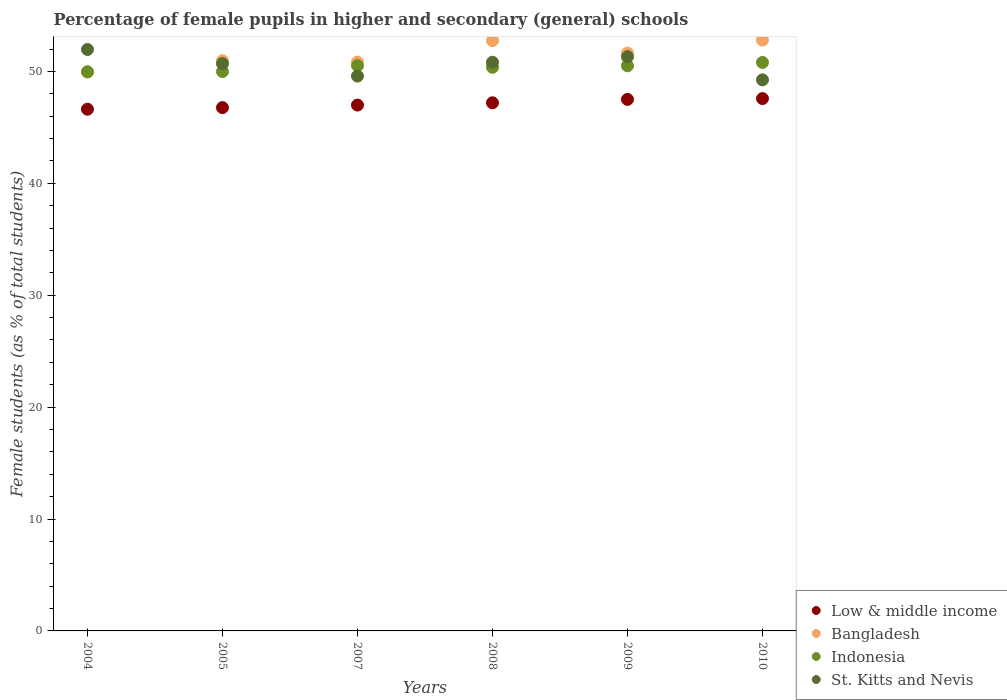How many different coloured dotlines are there?
Keep it short and to the point. 4. What is the percentage of female pupils in higher and secondary schools in Low & middle income in 2004?
Offer a very short reply. 46.62. Across all years, what is the maximum percentage of female pupils in higher and secondary schools in Indonesia?
Your response must be concise. 50.8. Across all years, what is the minimum percentage of female pupils in higher and secondary schools in Indonesia?
Your response must be concise. 49.97. In which year was the percentage of female pupils in higher and secondary schools in St. Kitts and Nevis maximum?
Offer a very short reply. 2004. In which year was the percentage of female pupils in higher and secondary schools in St. Kitts and Nevis minimum?
Your answer should be very brief. 2010. What is the total percentage of female pupils in higher and secondary schools in Indonesia in the graph?
Your answer should be compact. 302.14. What is the difference between the percentage of female pupils in higher and secondary schools in St. Kitts and Nevis in 2008 and that in 2010?
Your answer should be very brief. 1.57. What is the difference between the percentage of female pupils in higher and secondary schools in Low & middle income in 2007 and the percentage of female pupils in higher and secondary schools in Bangladesh in 2008?
Provide a short and direct response. -5.76. What is the average percentage of female pupils in higher and secondary schools in St. Kitts and Nevis per year?
Ensure brevity in your answer.  50.6. In the year 2009, what is the difference between the percentage of female pupils in higher and secondary schools in Low & middle income and percentage of female pupils in higher and secondary schools in Indonesia?
Your answer should be very brief. -3. In how many years, is the percentage of female pupils in higher and secondary schools in Bangladesh greater than 46 %?
Make the answer very short. 6. What is the ratio of the percentage of female pupils in higher and secondary schools in Bangladesh in 2005 to that in 2010?
Ensure brevity in your answer.  0.97. What is the difference between the highest and the second highest percentage of female pupils in higher and secondary schools in St. Kitts and Nevis?
Make the answer very short. 0.65. What is the difference between the highest and the lowest percentage of female pupils in higher and secondary schools in St. Kitts and Nevis?
Provide a succinct answer. 2.71. In how many years, is the percentage of female pupils in higher and secondary schools in Indonesia greater than the average percentage of female pupils in higher and secondary schools in Indonesia taken over all years?
Make the answer very short. 4. Is the sum of the percentage of female pupils in higher and secondary schools in Indonesia in 2004 and 2007 greater than the maximum percentage of female pupils in higher and secondary schools in Low & middle income across all years?
Offer a very short reply. Yes. Is it the case that in every year, the sum of the percentage of female pupils in higher and secondary schools in Bangladesh and percentage of female pupils in higher and secondary schools in St. Kitts and Nevis  is greater than the sum of percentage of female pupils in higher and secondary schools in Low & middle income and percentage of female pupils in higher and secondary schools in Indonesia?
Your response must be concise. No. Does the percentage of female pupils in higher and secondary schools in Bangladesh monotonically increase over the years?
Offer a terse response. No. Is the percentage of female pupils in higher and secondary schools in St. Kitts and Nevis strictly less than the percentage of female pupils in higher and secondary schools in Bangladesh over the years?
Keep it short and to the point. No. How many dotlines are there?
Provide a succinct answer. 4. How many years are there in the graph?
Your answer should be very brief. 6. What is the difference between two consecutive major ticks on the Y-axis?
Provide a short and direct response. 10. How many legend labels are there?
Make the answer very short. 4. How are the legend labels stacked?
Keep it short and to the point. Vertical. What is the title of the graph?
Ensure brevity in your answer.  Percentage of female pupils in higher and secondary (general) schools. What is the label or title of the Y-axis?
Offer a very short reply. Female students (as % of total students). What is the Female students (as % of total students) of Low & middle income in 2004?
Offer a very short reply. 46.62. What is the Female students (as % of total students) of Bangladesh in 2004?
Offer a terse response. 49.95. What is the Female students (as % of total students) in Indonesia in 2004?
Your response must be concise. 49.97. What is the Female students (as % of total students) of St. Kitts and Nevis in 2004?
Your response must be concise. 51.96. What is the Female students (as % of total students) of Low & middle income in 2005?
Make the answer very short. 46.76. What is the Female students (as % of total students) in Bangladesh in 2005?
Provide a short and direct response. 50.96. What is the Female students (as % of total students) of Indonesia in 2005?
Offer a terse response. 49.99. What is the Female students (as % of total students) in St. Kitts and Nevis in 2005?
Make the answer very short. 50.7. What is the Female students (as % of total students) of Low & middle income in 2007?
Provide a short and direct response. 46.99. What is the Female students (as % of total students) in Bangladesh in 2007?
Offer a terse response. 50.83. What is the Female students (as % of total students) of Indonesia in 2007?
Your answer should be compact. 50.51. What is the Female students (as % of total students) in St. Kitts and Nevis in 2007?
Provide a succinct answer. 49.58. What is the Female students (as % of total students) of Low & middle income in 2008?
Provide a succinct answer. 47.2. What is the Female students (as % of total students) in Bangladesh in 2008?
Make the answer very short. 52.76. What is the Female students (as % of total students) of Indonesia in 2008?
Provide a short and direct response. 50.37. What is the Female students (as % of total students) of St. Kitts and Nevis in 2008?
Provide a short and direct response. 50.82. What is the Female students (as % of total students) of Low & middle income in 2009?
Make the answer very short. 47.5. What is the Female students (as % of total students) of Bangladesh in 2009?
Ensure brevity in your answer.  51.63. What is the Female students (as % of total students) of Indonesia in 2009?
Ensure brevity in your answer.  50.5. What is the Female students (as % of total students) of St. Kitts and Nevis in 2009?
Make the answer very short. 51.31. What is the Female students (as % of total students) of Low & middle income in 2010?
Provide a succinct answer. 47.57. What is the Female students (as % of total students) in Bangladesh in 2010?
Your response must be concise. 52.8. What is the Female students (as % of total students) of Indonesia in 2010?
Your answer should be very brief. 50.8. What is the Female students (as % of total students) in St. Kitts and Nevis in 2010?
Offer a terse response. 49.25. Across all years, what is the maximum Female students (as % of total students) of Low & middle income?
Offer a terse response. 47.57. Across all years, what is the maximum Female students (as % of total students) in Bangladesh?
Give a very brief answer. 52.8. Across all years, what is the maximum Female students (as % of total students) in Indonesia?
Your response must be concise. 50.8. Across all years, what is the maximum Female students (as % of total students) of St. Kitts and Nevis?
Provide a succinct answer. 51.96. Across all years, what is the minimum Female students (as % of total students) in Low & middle income?
Keep it short and to the point. 46.62. Across all years, what is the minimum Female students (as % of total students) in Bangladesh?
Make the answer very short. 49.95. Across all years, what is the minimum Female students (as % of total students) in Indonesia?
Your answer should be very brief. 49.97. Across all years, what is the minimum Female students (as % of total students) in St. Kitts and Nevis?
Offer a very short reply. 49.25. What is the total Female students (as % of total students) of Low & middle income in the graph?
Make the answer very short. 282.65. What is the total Female students (as % of total students) of Bangladesh in the graph?
Offer a terse response. 308.93. What is the total Female students (as % of total students) in Indonesia in the graph?
Give a very brief answer. 302.14. What is the total Female students (as % of total students) of St. Kitts and Nevis in the graph?
Your response must be concise. 303.61. What is the difference between the Female students (as % of total students) in Low & middle income in 2004 and that in 2005?
Give a very brief answer. -0.14. What is the difference between the Female students (as % of total students) of Bangladesh in 2004 and that in 2005?
Provide a succinct answer. -1.01. What is the difference between the Female students (as % of total students) of Indonesia in 2004 and that in 2005?
Offer a terse response. -0.02. What is the difference between the Female students (as % of total students) in St. Kitts and Nevis in 2004 and that in 2005?
Offer a terse response. 1.26. What is the difference between the Female students (as % of total students) in Low & middle income in 2004 and that in 2007?
Give a very brief answer. -0.37. What is the difference between the Female students (as % of total students) in Bangladesh in 2004 and that in 2007?
Your answer should be very brief. -0.88. What is the difference between the Female students (as % of total students) of Indonesia in 2004 and that in 2007?
Make the answer very short. -0.55. What is the difference between the Female students (as % of total students) of St. Kitts and Nevis in 2004 and that in 2007?
Ensure brevity in your answer.  2.38. What is the difference between the Female students (as % of total students) in Low & middle income in 2004 and that in 2008?
Provide a succinct answer. -0.57. What is the difference between the Female students (as % of total students) in Bangladesh in 2004 and that in 2008?
Your response must be concise. -2.81. What is the difference between the Female students (as % of total students) of Indonesia in 2004 and that in 2008?
Ensure brevity in your answer.  -0.4. What is the difference between the Female students (as % of total students) of St. Kitts and Nevis in 2004 and that in 2008?
Keep it short and to the point. 1.14. What is the difference between the Female students (as % of total students) of Low & middle income in 2004 and that in 2009?
Your answer should be compact. -0.88. What is the difference between the Female students (as % of total students) in Bangladesh in 2004 and that in 2009?
Ensure brevity in your answer.  -1.68. What is the difference between the Female students (as % of total students) of Indonesia in 2004 and that in 2009?
Your answer should be compact. -0.54. What is the difference between the Female students (as % of total students) of St. Kitts and Nevis in 2004 and that in 2009?
Your answer should be very brief. 0.65. What is the difference between the Female students (as % of total students) of Low & middle income in 2004 and that in 2010?
Offer a very short reply. -0.95. What is the difference between the Female students (as % of total students) of Bangladesh in 2004 and that in 2010?
Your answer should be compact. -2.85. What is the difference between the Female students (as % of total students) of Indonesia in 2004 and that in 2010?
Provide a short and direct response. -0.84. What is the difference between the Female students (as % of total students) of St. Kitts and Nevis in 2004 and that in 2010?
Offer a terse response. 2.71. What is the difference between the Female students (as % of total students) of Low & middle income in 2005 and that in 2007?
Provide a short and direct response. -0.23. What is the difference between the Female students (as % of total students) of Bangladesh in 2005 and that in 2007?
Offer a very short reply. 0.13. What is the difference between the Female students (as % of total students) of Indonesia in 2005 and that in 2007?
Your answer should be very brief. -0.53. What is the difference between the Female students (as % of total students) in St. Kitts and Nevis in 2005 and that in 2007?
Keep it short and to the point. 1.12. What is the difference between the Female students (as % of total students) in Low & middle income in 2005 and that in 2008?
Keep it short and to the point. -0.43. What is the difference between the Female students (as % of total students) of Bangladesh in 2005 and that in 2008?
Offer a terse response. -1.8. What is the difference between the Female students (as % of total students) in Indonesia in 2005 and that in 2008?
Provide a succinct answer. -0.38. What is the difference between the Female students (as % of total students) of St. Kitts and Nevis in 2005 and that in 2008?
Offer a terse response. -0.12. What is the difference between the Female students (as % of total students) in Low & middle income in 2005 and that in 2009?
Offer a very short reply. -0.74. What is the difference between the Female students (as % of total students) of Bangladesh in 2005 and that in 2009?
Offer a very short reply. -0.68. What is the difference between the Female students (as % of total students) of Indonesia in 2005 and that in 2009?
Offer a terse response. -0.52. What is the difference between the Female students (as % of total students) in St. Kitts and Nevis in 2005 and that in 2009?
Make the answer very short. -0.61. What is the difference between the Female students (as % of total students) of Low & middle income in 2005 and that in 2010?
Ensure brevity in your answer.  -0.81. What is the difference between the Female students (as % of total students) in Bangladesh in 2005 and that in 2010?
Keep it short and to the point. -1.85. What is the difference between the Female students (as % of total students) in Indonesia in 2005 and that in 2010?
Your response must be concise. -0.81. What is the difference between the Female students (as % of total students) in St. Kitts and Nevis in 2005 and that in 2010?
Provide a short and direct response. 1.45. What is the difference between the Female students (as % of total students) of Low & middle income in 2007 and that in 2008?
Give a very brief answer. -0.2. What is the difference between the Female students (as % of total students) in Bangladesh in 2007 and that in 2008?
Make the answer very short. -1.93. What is the difference between the Female students (as % of total students) of Indonesia in 2007 and that in 2008?
Your answer should be very brief. 0.15. What is the difference between the Female students (as % of total students) in St. Kitts and Nevis in 2007 and that in 2008?
Your answer should be very brief. -1.24. What is the difference between the Female students (as % of total students) of Low & middle income in 2007 and that in 2009?
Ensure brevity in your answer.  -0.51. What is the difference between the Female students (as % of total students) of Bangladesh in 2007 and that in 2009?
Your answer should be compact. -0.8. What is the difference between the Female students (as % of total students) in Indonesia in 2007 and that in 2009?
Offer a terse response. 0.01. What is the difference between the Female students (as % of total students) in St. Kitts and Nevis in 2007 and that in 2009?
Provide a short and direct response. -1.73. What is the difference between the Female students (as % of total students) of Low & middle income in 2007 and that in 2010?
Make the answer very short. -0.58. What is the difference between the Female students (as % of total students) of Bangladesh in 2007 and that in 2010?
Your answer should be very brief. -1.97. What is the difference between the Female students (as % of total students) of Indonesia in 2007 and that in 2010?
Keep it short and to the point. -0.29. What is the difference between the Female students (as % of total students) in St. Kitts and Nevis in 2007 and that in 2010?
Ensure brevity in your answer.  0.33. What is the difference between the Female students (as % of total students) in Low & middle income in 2008 and that in 2009?
Your response must be concise. -0.3. What is the difference between the Female students (as % of total students) in Bangladesh in 2008 and that in 2009?
Provide a short and direct response. 1.12. What is the difference between the Female students (as % of total students) of Indonesia in 2008 and that in 2009?
Provide a short and direct response. -0.13. What is the difference between the Female students (as % of total students) of St. Kitts and Nevis in 2008 and that in 2009?
Your answer should be compact. -0.49. What is the difference between the Female students (as % of total students) of Low & middle income in 2008 and that in 2010?
Offer a terse response. -0.38. What is the difference between the Female students (as % of total students) in Bangladesh in 2008 and that in 2010?
Offer a very short reply. -0.05. What is the difference between the Female students (as % of total students) in Indonesia in 2008 and that in 2010?
Provide a succinct answer. -0.43. What is the difference between the Female students (as % of total students) of St. Kitts and Nevis in 2008 and that in 2010?
Offer a terse response. 1.57. What is the difference between the Female students (as % of total students) in Low & middle income in 2009 and that in 2010?
Make the answer very short. -0.07. What is the difference between the Female students (as % of total students) of Bangladesh in 2009 and that in 2010?
Provide a short and direct response. -1.17. What is the difference between the Female students (as % of total students) of Indonesia in 2009 and that in 2010?
Make the answer very short. -0.3. What is the difference between the Female students (as % of total students) of St. Kitts and Nevis in 2009 and that in 2010?
Ensure brevity in your answer.  2.07. What is the difference between the Female students (as % of total students) in Low & middle income in 2004 and the Female students (as % of total students) in Bangladesh in 2005?
Ensure brevity in your answer.  -4.34. What is the difference between the Female students (as % of total students) of Low & middle income in 2004 and the Female students (as % of total students) of Indonesia in 2005?
Your answer should be very brief. -3.37. What is the difference between the Female students (as % of total students) of Low & middle income in 2004 and the Female students (as % of total students) of St. Kitts and Nevis in 2005?
Your answer should be compact. -4.08. What is the difference between the Female students (as % of total students) in Bangladesh in 2004 and the Female students (as % of total students) in Indonesia in 2005?
Ensure brevity in your answer.  -0.04. What is the difference between the Female students (as % of total students) of Bangladesh in 2004 and the Female students (as % of total students) of St. Kitts and Nevis in 2005?
Your answer should be compact. -0.75. What is the difference between the Female students (as % of total students) in Indonesia in 2004 and the Female students (as % of total students) in St. Kitts and Nevis in 2005?
Make the answer very short. -0.73. What is the difference between the Female students (as % of total students) of Low & middle income in 2004 and the Female students (as % of total students) of Bangladesh in 2007?
Your answer should be very brief. -4.21. What is the difference between the Female students (as % of total students) of Low & middle income in 2004 and the Female students (as % of total students) of Indonesia in 2007?
Your response must be concise. -3.89. What is the difference between the Female students (as % of total students) in Low & middle income in 2004 and the Female students (as % of total students) in St. Kitts and Nevis in 2007?
Provide a succinct answer. -2.96. What is the difference between the Female students (as % of total students) of Bangladesh in 2004 and the Female students (as % of total students) of Indonesia in 2007?
Provide a succinct answer. -0.56. What is the difference between the Female students (as % of total students) in Bangladesh in 2004 and the Female students (as % of total students) in St. Kitts and Nevis in 2007?
Make the answer very short. 0.37. What is the difference between the Female students (as % of total students) in Indonesia in 2004 and the Female students (as % of total students) in St. Kitts and Nevis in 2007?
Your answer should be very brief. 0.39. What is the difference between the Female students (as % of total students) in Low & middle income in 2004 and the Female students (as % of total students) in Bangladesh in 2008?
Ensure brevity in your answer.  -6.13. What is the difference between the Female students (as % of total students) of Low & middle income in 2004 and the Female students (as % of total students) of Indonesia in 2008?
Your response must be concise. -3.75. What is the difference between the Female students (as % of total students) of Low & middle income in 2004 and the Female students (as % of total students) of St. Kitts and Nevis in 2008?
Your response must be concise. -4.2. What is the difference between the Female students (as % of total students) in Bangladesh in 2004 and the Female students (as % of total students) in Indonesia in 2008?
Offer a terse response. -0.42. What is the difference between the Female students (as % of total students) of Bangladesh in 2004 and the Female students (as % of total students) of St. Kitts and Nevis in 2008?
Provide a succinct answer. -0.87. What is the difference between the Female students (as % of total students) in Indonesia in 2004 and the Female students (as % of total students) in St. Kitts and Nevis in 2008?
Your answer should be compact. -0.85. What is the difference between the Female students (as % of total students) in Low & middle income in 2004 and the Female students (as % of total students) in Bangladesh in 2009?
Ensure brevity in your answer.  -5.01. What is the difference between the Female students (as % of total students) in Low & middle income in 2004 and the Female students (as % of total students) in Indonesia in 2009?
Offer a terse response. -3.88. What is the difference between the Female students (as % of total students) of Low & middle income in 2004 and the Female students (as % of total students) of St. Kitts and Nevis in 2009?
Provide a succinct answer. -4.69. What is the difference between the Female students (as % of total students) in Bangladesh in 2004 and the Female students (as % of total students) in Indonesia in 2009?
Provide a succinct answer. -0.55. What is the difference between the Female students (as % of total students) of Bangladesh in 2004 and the Female students (as % of total students) of St. Kitts and Nevis in 2009?
Offer a terse response. -1.36. What is the difference between the Female students (as % of total students) in Indonesia in 2004 and the Female students (as % of total students) in St. Kitts and Nevis in 2009?
Your answer should be compact. -1.35. What is the difference between the Female students (as % of total students) in Low & middle income in 2004 and the Female students (as % of total students) in Bangladesh in 2010?
Make the answer very short. -6.18. What is the difference between the Female students (as % of total students) of Low & middle income in 2004 and the Female students (as % of total students) of Indonesia in 2010?
Ensure brevity in your answer.  -4.18. What is the difference between the Female students (as % of total students) of Low & middle income in 2004 and the Female students (as % of total students) of St. Kitts and Nevis in 2010?
Keep it short and to the point. -2.62. What is the difference between the Female students (as % of total students) in Bangladesh in 2004 and the Female students (as % of total students) in Indonesia in 2010?
Give a very brief answer. -0.85. What is the difference between the Female students (as % of total students) of Bangladesh in 2004 and the Female students (as % of total students) of St. Kitts and Nevis in 2010?
Provide a short and direct response. 0.7. What is the difference between the Female students (as % of total students) of Indonesia in 2004 and the Female students (as % of total students) of St. Kitts and Nevis in 2010?
Your response must be concise. 0.72. What is the difference between the Female students (as % of total students) of Low & middle income in 2005 and the Female students (as % of total students) of Bangladesh in 2007?
Offer a very short reply. -4.07. What is the difference between the Female students (as % of total students) in Low & middle income in 2005 and the Female students (as % of total students) in Indonesia in 2007?
Ensure brevity in your answer.  -3.75. What is the difference between the Female students (as % of total students) of Low & middle income in 2005 and the Female students (as % of total students) of St. Kitts and Nevis in 2007?
Offer a terse response. -2.82. What is the difference between the Female students (as % of total students) in Bangladesh in 2005 and the Female students (as % of total students) in Indonesia in 2007?
Offer a very short reply. 0.44. What is the difference between the Female students (as % of total students) of Bangladesh in 2005 and the Female students (as % of total students) of St. Kitts and Nevis in 2007?
Ensure brevity in your answer.  1.38. What is the difference between the Female students (as % of total students) in Indonesia in 2005 and the Female students (as % of total students) in St. Kitts and Nevis in 2007?
Give a very brief answer. 0.41. What is the difference between the Female students (as % of total students) of Low & middle income in 2005 and the Female students (as % of total students) of Bangladesh in 2008?
Your answer should be compact. -5.99. What is the difference between the Female students (as % of total students) of Low & middle income in 2005 and the Female students (as % of total students) of Indonesia in 2008?
Offer a terse response. -3.6. What is the difference between the Female students (as % of total students) in Low & middle income in 2005 and the Female students (as % of total students) in St. Kitts and Nevis in 2008?
Offer a very short reply. -4.05. What is the difference between the Female students (as % of total students) of Bangladesh in 2005 and the Female students (as % of total students) of Indonesia in 2008?
Your response must be concise. 0.59. What is the difference between the Female students (as % of total students) in Bangladesh in 2005 and the Female students (as % of total students) in St. Kitts and Nevis in 2008?
Your answer should be compact. 0.14. What is the difference between the Female students (as % of total students) of Indonesia in 2005 and the Female students (as % of total students) of St. Kitts and Nevis in 2008?
Your answer should be compact. -0.83. What is the difference between the Female students (as % of total students) of Low & middle income in 2005 and the Female students (as % of total students) of Bangladesh in 2009?
Keep it short and to the point. -4.87. What is the difference between the Female students (as % of total students) of Low & middle income in 2005 and the Female students (as % of total students) of Indonesia in 2009?
Your response must be concise. -3.74. What is the difference between the Female students (as % of total students) in Low & middle income in 2005 and the Female students (as % of total students) in St. Kitts and Nevis in 2009?
Keep it short and to the point. -4.55. What is the difference between the Female students (as % of total students) in Bangladesh in 2005 and the Female students (as % of total students) in Indonesia in 2009?
Offer a terse response. 0.46. What is the difference between the Female students (as % of total students) in Bangladesh in 2005 and the Female students (as % of total students) in St. Kitts and Nevis in 2009?
Your response must be concise. -0.35. What is the difference between the Female students (as % of total students) in Indonesia in 2005 and the Female students (as % of total students) in St. Kitts and Nevis in 2009?
Your response must be concise. -1.32. What is the difference between the Female students (as % of total students) in Low & middle income in 2005 and the Female students (as % of total students) in Bangladesh in 2010?
Give a very brief answer. -6.04. What is the difference between the Female students (as % of total students) of Low & middle income in 2005 and the Female students (as % of total students) of Indonesia in 2010?
Your answer should be compact. -4.04. What is the difference between the Female students (as % of total students) of Low & middle income in 2005 and the Female students (as % of total students) of St. Kitts and Nevis in 2010?
Your answer should be compact. -2.48. What is the difference between the Female students (as % of total students) in Bangladesh in 2005 and the Female students (as % of total students) in Indonesia in 2010?
Offer a terse response. 0.16. What is the difference between the Female students (as % of total students) of Bangladesh in 2005 and the Female students (as % of total students) of St. Kitts and Nevis in 2010?
Give a very brief answer. 1.71. What is the difference between the Female students (as % of total students) of Indonesia in 2005 and the Female students (as % of total students) of St. Kitts and Nevis in 2010?
Make the answer very short. 0.74. What is the difference between the Female students (as % of total students) in Low & middle income in 2007 and the Female students (as % of total students) in Bangladesh in 2008?
Provide a short and direct response. -5.76. What is the difference between the Female students (as % of total students) in Low & middle income in 2007 and the Female students (as % of total students) in Indonesia in 2008?
Your response must be concise. -3.38. What is the difference between the Female students (as % of total students) of Low & middle income in 2007 and the Female students (as % of total students) of St. Kitts and Nevis in 2008?
Provide a succinct answer. -3.83. What is the difference between the Female students (as % of total students) in Bangladesh in 2007 and the Female students (as % of total students) in Indonesia in 2008?
Provide a short and direct response. 0.46. What is the difference between the Female students (as % of total students) in Bangladesh in 2007 and the Female students (as % of total students) in St. Kitts and Nevis in 2008?
Ensure brevity in your answer.  0.01. What is the difference between the Female students (as % of total students) of Indonesia in 2007 and the Female students (as % of total students) of St. Kitts and Nevis in 2008?
Give a very brief answer. -0.31. What is the difference between the Female students (as % of total students) of Low & middle income in 2007 and the Female students (as % of total students) of Bangladesh in 2009?
Ensure brevity in your answer.  -4.64. What is the difference between the Female students (as % of total students) in Low & middle income in 2007 and the Female students (as % of total students) in Indonesia in 2009?
Ensure brevity in your answer.  -3.51. What is the difference between the Female students (as % of total students) of Low & middle income in 2007 and the Female students (as % of total students) of St. Kitts and Nevis in 2009?
Offer a terse response. -4.32. What is the difference between the Female students (as % of total students) of Bangladesh in 2007 and the Female students (as % of total students) of Indonesia in 2009?
Make the answer very short. 0.33. What is the difference between the Female students (as % of total students) of Bangladesh in 2007 and the Female students (as % of total students) of St. Kitts and Nevis in 2009?
Provide a succinct answer. -0.48. What is the difference between the Female students (as % of total students) of Indonesia in 2007 and the Female students (as % of total students) of St. Kitts and Nevis in 2009?
Ensure brevity in your answer.  -0.8. What is the difference between the Female students (as % of total students) of Low & middle income in 2007 and the Female students (as % of total students) of Bangladesh in 2010?
Provide a succinct answer. -5.81. What is the difference between the Female students (as % of total students) in Low & middle income in 2007 and the Female students (as % of total students) in Indonesia in 2010?
Keep it short and to the point. -3.81. What is the difference between the Female students (as % of total students) in Low & middle income in 2007 and the Female students (as % of total students) in St. Kitts and Nevis in 2010?
Your response must be concise. -2.25. What is the difference between the Female students (as % of total students) in Bangladesh in 2007 and the Female students (as % of total students) in Indonesia in 2010?
Make the answer very short. 0.03. What is the difference between the Female students (as % of total students) of Bangladesh in 2007 and the Female students (as % of total students) of St. Kitts and Nevis in 2010?
Provide a short and direct response. 1.58. What is the difference between the Female students (as % of total students) in Indonesia in 2007 and the Female students (as % of total students) in St. Kitts and Nevis in 2010?
Your answer should be compact. 1.27. What is the difference between the Female students (as % of total students) of Low & middle income in 2008 and the Female students (as % of total students) of Bangladesh in 2009?
Your response must be concise. -4.44. What is the difference between the Female students (as % of total students) of Low & middle income in 2008 and the Female students (as % of total students) of Indonesia in 2009?
Offer a terse response. -3.31. What is the difference between the Female students (as % of total students) in Low & middle income in 2008 and the Female students (as % of total students) in St. Kitts and Nevis in 2009?
Give a very brief answer. -4.12. What is the difference between the Female students (as % of total students) of Bangladesh in 2008 and the Female students (as % of total students) of Indonesia in 2009?
Give a very brief answer. 2.25. What is the difference between the Female students (as % of total students) of Bangladesh in 2008 and the Female students (as % of total students) of St. Kitts and Nevis in 2009?
Give a very brief answer. 1.44. What is the difference between the Female students (as % of total students) of Indonesia in 2008 and the Female students (as % of total students) of St. Kitts and Nevis in 2009?
Provide a succinct answer. -0.94. What is the difference between the Female students (as % of total students) in Low & middle income in 2008 and the Female students (as % of total students) in Bangladesh in 2010?
Ensure brevity in your answer.  -5.61. What is the difference between the Female students (as % of total students) in Low & middle income in 2008 and the Female students (as % of total students) in Indonesia in 2010?
Ensure brevity in your answer.  -3.61. What is the difference between the Female students (as % of total students) of Low & middle income in 2008 and the Female students (as % of total students) of St. Kitts and Nevis in 2010?
Ensure brevity in your answer.  -2.05. What is the difference between the Female students (as % of total students) in Bangladesh in 2008 and the Female students (as % of total students) in Indonesia in 2010?
Offer a terse response. 1.96. What is the difference between the Female students (as % of total students) of Bangladesh in 2008 and the Female students (as % of total students) of St. Kitts and Nevis in 2010?
Your answer should be very brief. 3.51. What is the difference between the Female students (as % of total students) of Indonesia in 2008 and the Female students (as % of total students) of St. Kitts and Nevis in 2010?
Provide a short and direct response. 1.12. What is the difference between the Female students (as % of total students) of Low & middle income in 2009 and the Female students (as % of total students) of Bangladesh in 2010?
Offer a terse response. -5.3. What is the difference between the Female students (as % of total students) of Low & middle income in 2009 and the Female students (as % of total students) of Indonesia in 2010?
Make the answer very short. -3.3. What is the difference between the Female students (as % of total students) in Low & middle income in 2009 and the Female students (as % of total students) in St. Kitts and Nevis in 2010?
Ensure brevity in your answer.  -1.75. What is the difference between the Female students (as % of total students) in Bangladesh in 2009 and the Female students (as % of total students) in Indonesia in 2010?
Your answer should be very brief. 0.83. What is the difference between the Female students (as % of total students) of Bangladesh in 2009 and the Female students (as % of total students) of St. Kitts and Nevis in 2010?
Your answer should be compact. 2.39. What is the difference between the Female students (as % of total students) in Indonesia in 2009 and the Female students (as % of total students) in St. Kitts and Nevis in 2010?
Give a very brief answer. 1.26. What is the average Female students (as % of total students) in Low & middle income per year?
Offer a very short reply. 47.11. What is the average Female students (as % of total students) of Bangladesh per year?
Offer a terse response. 51.49. What is the average Female students (as % of total students) of Indonesia per year?
Your answer should be very brief. 50.36. What is the average Female students (as % of total students) of St. Kitts and Nevis per year?
Give a very brief answer. 50.6. In the year 2004, what is the difference between the Female students (as % of total students) of Low & middle income and Female students (as % of total students) of Bangladesh?
Give a very brief answer. -3.33. In the year 2004, what is the difference between the Female students (as % of total students) in Low & middle income and Female students (as % of total students) in Indonesia?
Your answer should be compact. -3.34. In the year 2004, what is the difference between the Female students (as % of total students) in Low & middle income and Female students (as % of total students) in St. Kitts and Nevis?
Provide a succinct answer. -5.34. In the year 2004, what is the difference between the Female students (as % of total students) of Bangladesh and Female students (as % of total students) of Indonesia?
Your answer should be very brief. -0.02. In the year 2004, what is the difference between the Female students (as % of total students) in Bangladesh and Female students (as % of total students) in St. Kitts and Nevis?
Your answer should be very brief. -2.01. In the year 2004, what is the difference between the Female students (as % of total students) of Indonesia and Female students (as % of total students) of St. Kitts and Nevis?
Make the answer very short. -1.99. In the year 2005, what is the difference between the Female students (as % of total students) of Low & middle income and Female students (as % of total students) of Bangladesh?
Your answer should be compact. -4.19. In the year 2005, what is the difference between the Female students (as % of total students) in Low & middle income and Female students (as % of total students) in Indonesia?
Your answer should be compact. -3.22. In the year 2005, what is the difference between the Female students (as % of total students) in Low & middle income and Female students (as % of total students) in St. Kitts and Nevis?
Offer a very short reply. -3.93. In the year 2005, what is the difference between the Female students (as % of total students) in Bangladesh and Female students (as % of total students) in Indonesia?
Provide a short and direct response. 0.97. In the year 2005, what is the difference between the Female students (as % of total students) of Bangladesh and Female students (as % of total students) of St. Kitts and Nevis?
Ensure brevity in your answer.  0.26. In the year 2005, what is the difference between the Female students (as % of total students) of Indonesia and Female students (as % of total students) of St. Kitts and Nevis?
Your answer should be very brief. -0.71. In the year 2007, what is the difference between the Female students (as % of total students) in Low & middle income and Female students (as % of total students) in Bangladesh?
Offer a very short reply. -3.84. In the year 2007, what is the difference between the Female students (as % of total students) of Low & middle income and Female students (as % of total students) of Indonesia?
Provide a short and direct response. -3.52. In the year 2007, what is the difference between the Female students (as % of total students) in Low & middle income and Female students (as % of total students) in St. Kitts and Nevis?
Your answer should be compact. -2.59. In the year 2007, what is the difference between the Female students (as % of total students) of Bangladesh and Female students (as % of total students) of Indonesia?
Your response must be concise. 0.32. In the year 2007, what is the difference between the Female students (as % of total students) in Indonesia and Female students (as % of total students) in St. Kitts and Nevis?
Your answer should be very brief. 0.93. In the year 2008, what is the difference between the Female students (as % of total students) of Low & middle income and Female students (as % of total students) of Bangladesh?
Give a very brief answer. -5.56. In the year 2008, what is the difference between the Female students (as % of total students) in Low & middle income and Female students (as % of total students) in Indonesia?
Keep it short and to the point. -3.17. In the year 2008, what is the difference between the Female students (as % of total students) in Low & middle income and Female students (as % of total students) in St. Kitts and Nevis?
Offer a terse response. -3.62. In the year 2008, what is the difference between the Female students (as % of total students) in Bangladesh and Female students (as % of total students) in Indonesia?
Keep it short and to the point. 2.39. In the year 2008, what is the difference between the Female students (as % of total students) of Bangladesh and Female students (as % of total students) of St. Kitts and Nevis?
Keep it short and to the point. 1.94. In the year 2008, what is the difference between the Female students (as % of total students) of Indonesia and Female students (as % of total students) of St. Kitts and Nevis?
Your response must be concise. -0.45. In the year 2009, what is the difference between the Female students (as % of total students) of Low & middle income and Female students (as % of total students) of Bangladesh?
Keep it short and to the point. -4.13. In the year 2009, what is the difference between the Female students (as % of total students) in Low & middle income and Female students (as % of total students) in Indonesia?
Keep it short and to the point. -3. In the year 2009, what is the difference between the Female students (as % of total students) of Low & middle income and Female students (as % of total students) of St. Kitts and Nevis?
Ensure brevity in your answer.  -3.81. In the year 2009, what is the difference between the Female students (as % of total students) in Bangladesh and Female students (as % of total students) in Indonesia?
Offer a terse response. 1.13. In the year 2009, what is the difference between the Female students (as % of total students) in Bangladesh and Female students (as % of total students) in St. Kitts and Nevis?
Give a very brief answer. 0.32. In the year 2009, what is the difference between the Female students (as % of total students) of Indonesia and Female students (as % of total students) of St. Kitts and Nevis?
Provide a succinct answer. -0.81. In the year 2010, what is the difference between the Female students (as % of total students) in Low & middle income and Female students (as % of total students) in Bangladesh?
Make the answer very short. -5.23. In the year 2010, what is the difference between the Female students (as % of total students) of Low & middle income and Female students (as % of total students) of Indonesia?
Your answer should be very brief. -3.23. In the year 2010, what is the difference between the Female students (as % of total students) of Low & middle income and Female students (as % of total students) of St. Kitts and Nevis?
Your answer should be very brief. -1.67. In the year 2010, what is the difference between the Female students (as % of total students) in Bangladesh and Female students (as % of total students) in Indonesia?
Your response must be concise. 2. In the year 2010, what is the difference between the Female students (as % of total students) in Bangladesh and Female students (as % of total students) in St. Kitts and Nevis?
Make the answer very short. 3.56. In the year 2010, what is the difference between the Female students (as % of total students) in Indonesia and Female students (as % of total students) in St. Kitts and Nevis?
Provide a succinct answer. 1.56. What is the ratio of the Female students (as % of total students) of Low & middle income in 2004 to that in 2005?
Provide a short and direct response. 1. What is the ratio of the Female students (as % of total students) in Bangladesh in 2004 to that in 2005?
Provide a short and direct response. 0.98. What is the ratio of the Female students (as % of total students) in Indonesia in 2004 to that in 2005?
Provide a short and direct response. 1. What is the ratio of the Female students (as % of total students) in St. Kitts and Nevis in 2004 to that in 2005?
Offer a very short reply. 1.02. What is the ratio of the Female students (as % of total students) in Bangladesh in 2004 to that in 2007?
Keep it short and to the point. 0.98. What is the ratio of the Female students (as % of total students) of Indonesia in 2004 to that in 2007?
Your response must be concise. 0.99. What is the ratio of the Female students (as % of total students) of St. Kitts and Nevis in 2004 to that in 2007?
Keep it short and to the point. 1.05. What is the ratio of the Female students (as % of total students) in Low & middle income in 2004 to that in 2008?
Provide a succinct answer. 0.99. What is the ratio of the Female students (as % of total students) in Bangladesh in 2004 to that in 2008?
Keep it short and to the point. 0.95. What is the ratio of the Female students (as % of total students) of St. Kitts and Nevis in 2004 to that in 2008?
Provide a short and direct response. 1.02. What is the ratio of the Female students (as % of total students) of Low & middle income in 2004 to that in 2009?
Offer a terse response. 0.98. What is the ratio of the Female students (as % of total students) of Bangladesh in 2004 to that in 2009?
Your response must be concise. 0.97. What is the ratio of the Female students (as % of total students) of Indonesia in 2004 to that in 2009?
Your response must be concise. 0.99. What is the ratio of the Female students (as % of total students) of St. Kitts and Nevis in 2004 to that in 2009?
Provide a short and direct response. 1.01. What is the ratio of the Female students (as % of total students) of Low & middle income in 2004 to that in 2010?
Offer a terse response. 0.98. What is the ratio of the Female students (as % of total students) in Bangladesh in 2004 to that in 2010?
Make the answer very short. 0.95. What is the ratio of the Female students (as % of total students) in Indonesia in 2004 to that in 2010?
Ensure brevity in your answer.  0.98. What is the ratio of the Female students (as % of total students) of St. Kitts and Nevis in 2004 to that in 2010?
Your response must be concise. 1.06. What is the ratio of the Female students (as % of total students) of St. Kitts and Nevis in 2005 to that in 2007?
Give a very brief answer. 1.02. What is the ratio of the Female students (as % of total students) of Low & middle income in 2005 to that in 2008?
Your answer should be compact. 0.99. What is the ratio of the Female students (as % of total students) in Bangladesh in 2005 to that in 2008?
Ensure brevity in your answer.  0.97. What is the ratio of the Female students (as % of total students) of St. Kitts and Nevis in 2005 to that in 2008?
Your answer should be very brief. 1. What is the ratio of the Female students (as % of total students) in Low & middle income in 2005 to that in 2009?
Make the answer very short. 0.98. What is the ratio of the Female students (as % of total students) in Bangladesh in 2005 to that in 2009?
Your answer should be very brief. 0.99. What is the ratio of the Female students (as % of total students) of Indonesia in 2005 to that in 2009?
Offer a very short reply. 0.99. What is the ratio of the Female students (as % of total students) of St. Kitts and Nevis in 2005 to that in 2009?
Offer a terse response. 0.99. What is the ratio of the Female students (as % of total students) of Low & middle income in 2005 to that in 2010?
Provide a short and direct response. 0.98. What is the ratio of the Female students (as % of total students) of St. Kitts and Nevis in 2005 to that in 2010?
Your answer should be compact. 1.03. What is the ratio of the Female students (as % of total students) in Bangladesh in 2007 to that in 2008?
Provide a succinct answer. 0.96. What is the ratio of the Female students (as % of total students) of Indonesia in 2007 to that in 2008?
Provide a succinct answer. 1. What is the ratio of the Female students (as % of total students) in St. Kitts and Nevis in 2007 to that in 2008?
Give a very brief answer. 0.98. What is the ratio of the Female students (as % of total students) of Low & middle income in 2007 to that in 2009?
Keep it short and to the point. 0.99. What is the ratio of the Female students (as % of total students) in Bangladesh in 2007 to that in 2009?
Ensure brevity in your answer.  0.98. What is the ratio of the Female students (as % of total students) in Indonesia in 2007 to that in 2009?
Provide a short and direct response. 1. What is the ratio of the Female students (as % of total students) in St. Kitts and Nevis in 2007 to that in 2009?
Keep it short and to the point. 0.97. What is the ratio of the Female students (as % of total students) in Bangladesh in 2007 to that in 2010?
Ensure brevity in your answer.  0.96. What is the ratio of the Female students (as % of total students) in Indonesia in 2007 to that in 2010?
Provide a short and direct response. 0.99. What is the ratio of the Female students (as % of total students) of St. Kitts and Nevis in 2007 to that in 2010?
Offer a terse response. 1.01. What is the ratio of the Female students (as % of total students) in Bangladesh in 2008 to that in 2009?
Provide a short and direct response. 1.02. What is the ratio of the Female students (as % of total students) of St. Kitts and Nevis in 2008 to that in 2009?
Give a very brief answer. 0.99. What is the ratio of the Female students (as % of total students) in Indonesia in 2008 to that in 2010?
Offer a very short reply. 0.99. What is the ratio of the Female students (as % of total students) of St. Kitts and Nevis in 2008 to that in 2010?
Make the answer very short. 1.03. What is the ratio of the Female students (as % of total students) in Bangladesh in 2009 to that in 2010?
Your answer should be very brief. 0.98. What is the ratio of the Female students (as % of total students) in St. Kitts and Nevis in 2009 to that in 2010?
Make the answer very short. 1.04. What is the difference between the highest and the second highest Female students (as % of total students) in Low & middle income?
Your response must be concise. 0.07. What is the difference between the highest and the second highest Female students (as % of total students) in Bangladesh?
Provide a succinct answer. 0.05. What is the difference between the highest and the second highest Female students (as % of total students) of Indonesia?
Ensure brevity in your answer.  0.29. What is the difference between the highest and the second highest Female students (as % of total students) in St. Kitts and Nevis?
Provide a succinct answer. 0.65. What is the difference between the highest and the lowest Female students (as % of total students) of Low & middle income?
Provide a short and direct response. 0.95. What is the difference between the highest and the lowest Female students (as % of total students) in Bangladesh?
Provide a succinct answer. 2.85. What is the difference between the highest and the lowest Female students (as % of total students) in Indonesia?
Your response must be concise. 0.84. What is the difference between the highest and the lowest Female students (as % of total students) of St. Kitts and Nevis?
Make the answer very short. 2.71. 